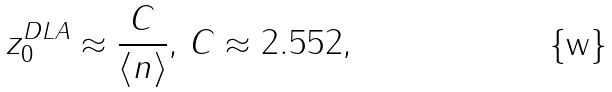<formula> <loc_0><loc_0><loc_500><loc_500>z _ { 0 } ^ { D L A } \approx \frac { C } { \langle n \rangle } , \, C \approx 2 . 5 5 2 ,</formula> 